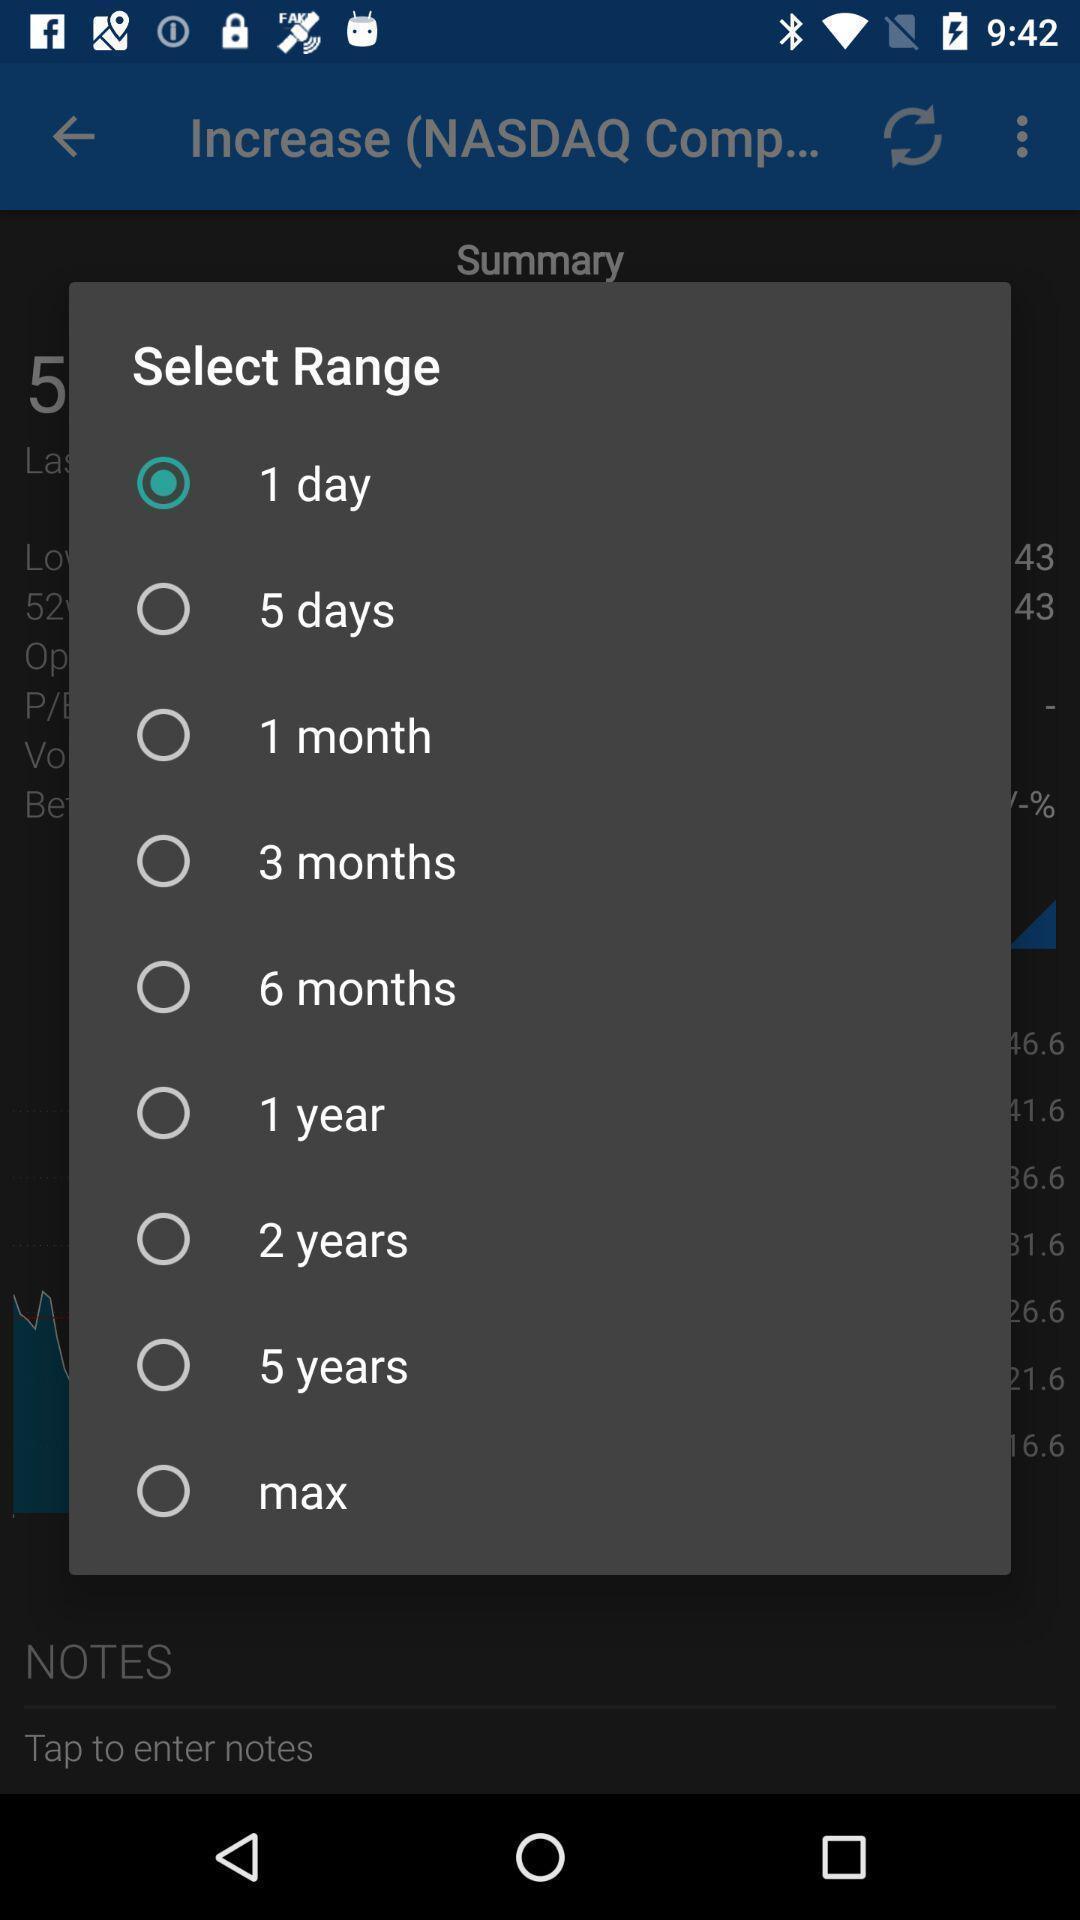What can you discern from this picture? Pop-up showing list of days to select range. 